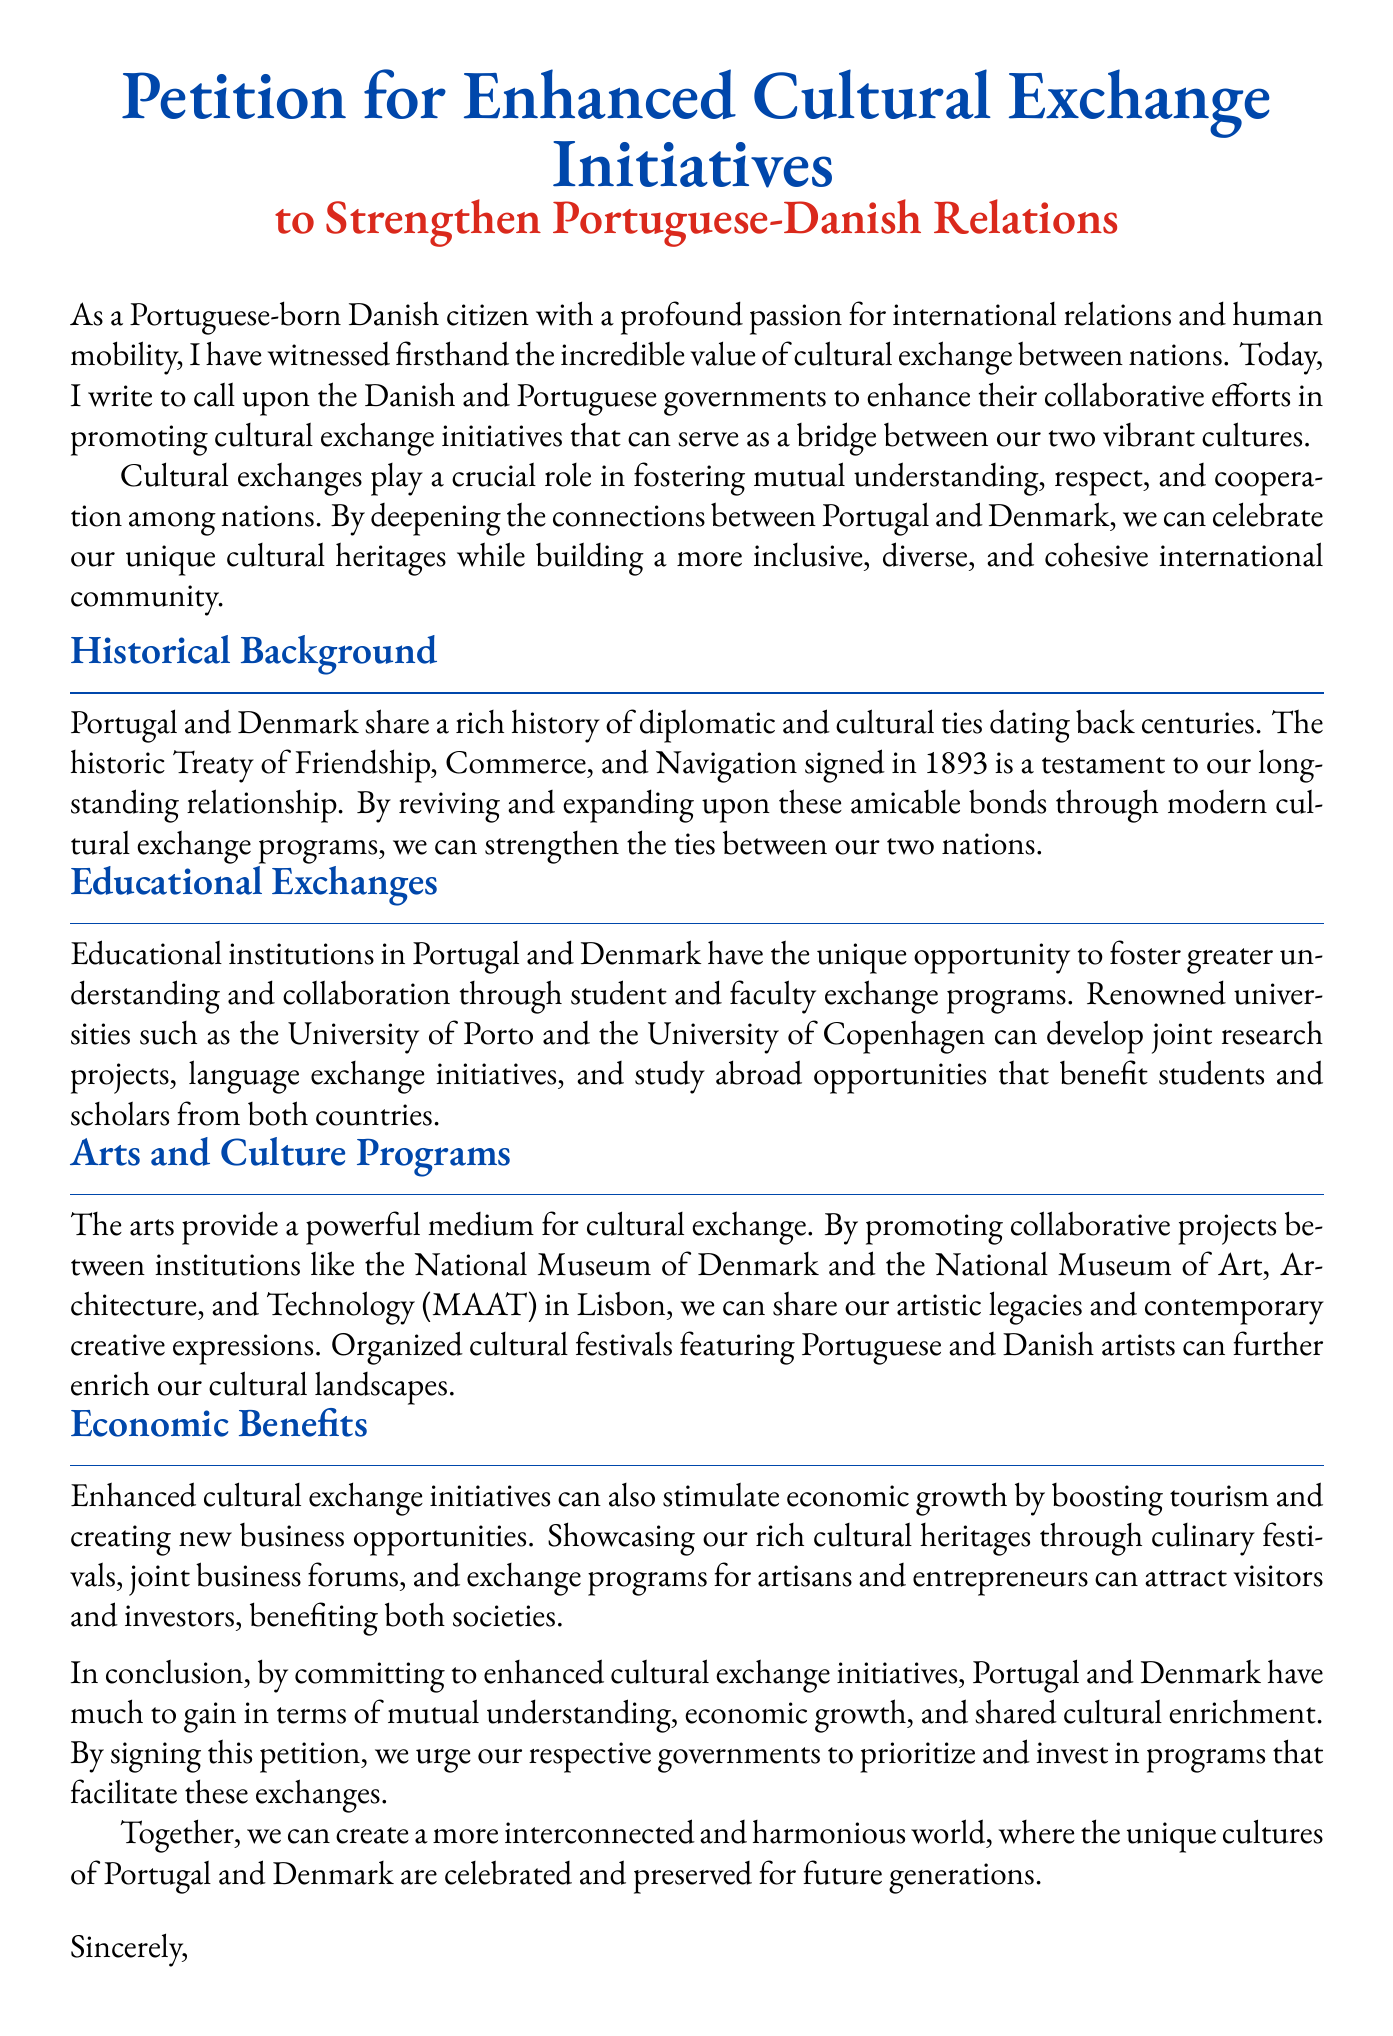What is the title of the petition? The title of the petition is stated prominently at the top of the document.
Answer: Petition for Enhanced Cultural Exchange Initiatives What year was the Treaty of Friendship signed? The document mentions that the Treaty of Friendship was signed in 1893.
Answer: 1893 Which universities are mentioned for educational exchanges? The document references specific universities that can foster collaboration through exchanges.
Answer: University of Porto and University of Copenhagen What is one medium mentioned for cultural exchange? The document highlights a specific medium that allows for cultural exchange.
Answer: Arts What economic benefit is linked to enhanced cultural exchange? The document outlines a specific economic outcome associated with cultural exchange initiatives.
Answer: Tourism Who is the author of the petition? The author's identity is revealed in the opening section of the document.
Answer: A Portuguese-born Danish citizen What is one cultural initiative suggested in the petition? The document proposes a type of cultural program to promote exchange.
Answer: Cultural festivals What role do arts institutions play in cultural exchange? The document specifies a particular function of arts institutions in facilitating cultural exchange.
Answer: Collaborative projects 